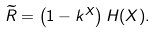Convert formula to latex. <formula><loc_0><loc_0><loc_500><loc_500>\widetilde { R } = \left ( 1 - k ^ { X } \right ) H ( X ) .</formula> 